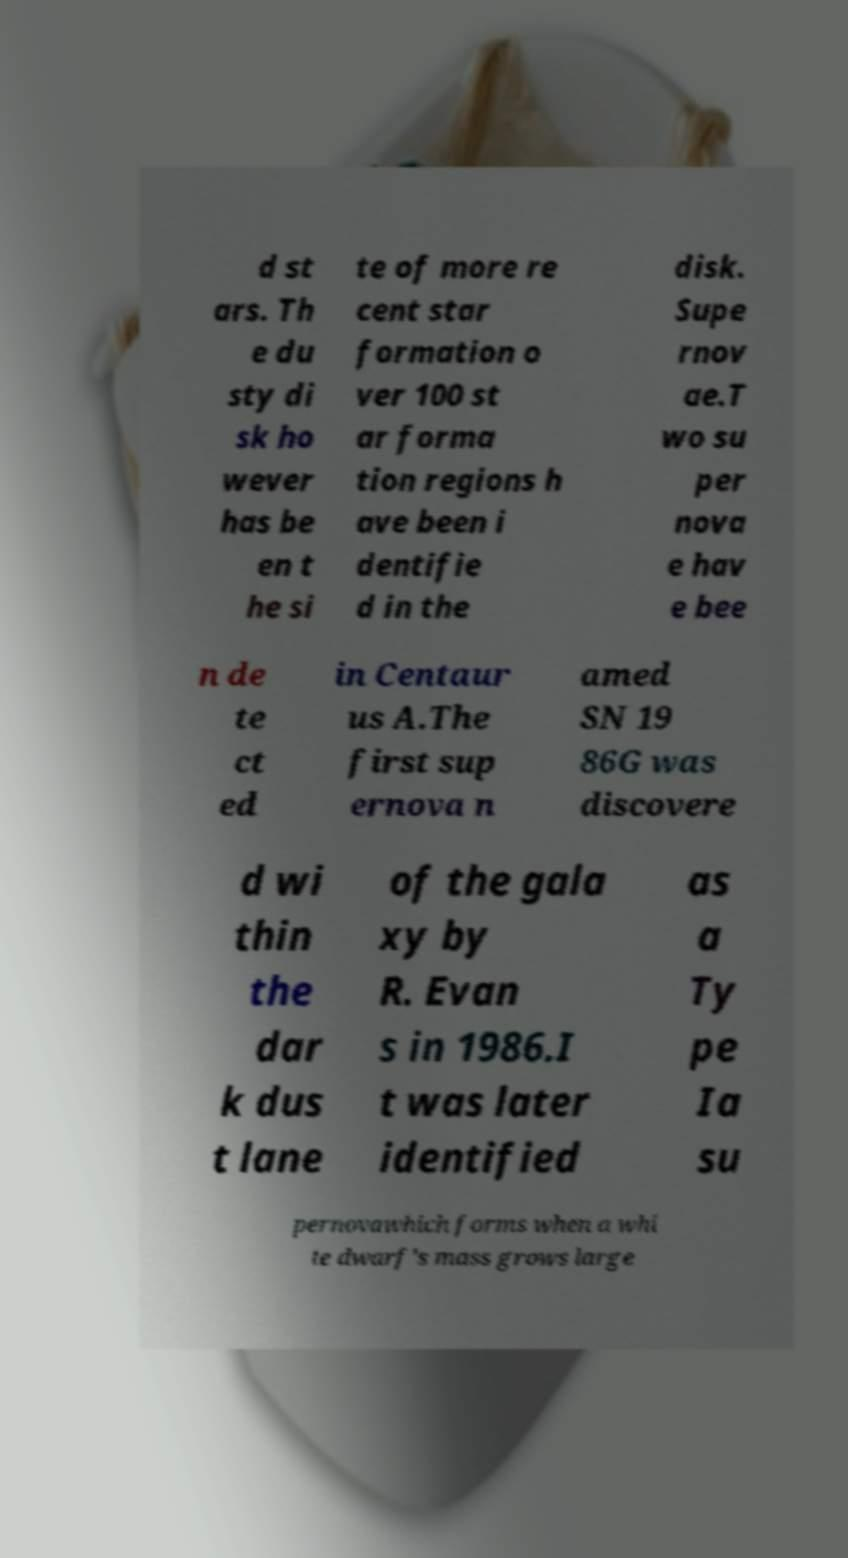Could you assist in decoding the text presented in this image and type it out clearly? d st ars. Th e du sty di sk ho wever has be en t he si te of more re cent star formation o ver 100 st ar forma tion regions h ave been i dentifie d in the disk. Supe rnov ae.T wo su per nova e hav e bee n de te ct ed in Centaur us A.The first sup ernova n amed SN 19 86G was discovere d wi thin the dar k dus t lane of the gala xy by R. Evan s in 1986.I t was later identified as a Ty pe Ia su pernovawhich forms when a whi te dwarf's mass grows large 